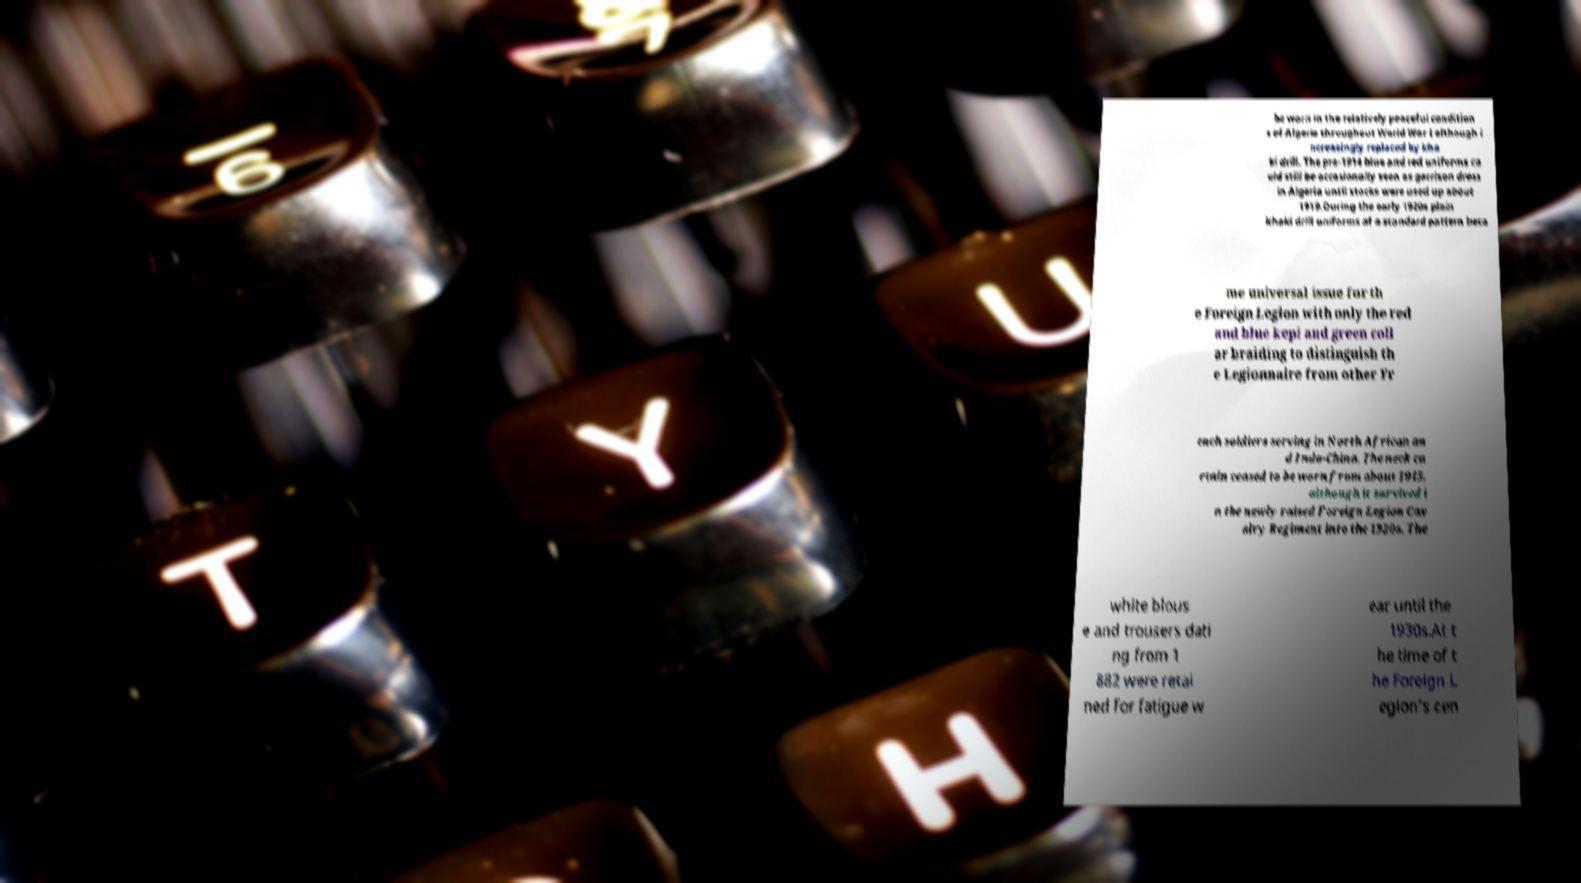Can you read and provide the text displayed in the image?This photo seems to have some interesting text. Can you extract and type it out for me? be worn in the relatively peaceful condition s of Algeria throughout World War I although i ncreasingly replaced by kha ki drill. The pre-1914 blue and red uniforms co uld still be occasionally seen as garrison dress in Algeria until stocks were used up about 1919.During the early 1920s plain khaki drill uniforms of a standard pattern beca me universal issue for th e Foreign Legion with only the red and blue kepi and green coll ar braiding to distinguish th e Legionnaire from other Fr ench soldiers serving in North African an d Indo-China. The neck cu rtain ceased to be worn from about 1915, although it survived i n the newly raised Foreign Legion Cav alry Regiment into the 1920s. The white blous e and trousers dati ng from 1 882 were retai ned for fatigue w ear until the 1930s.At t he time of t he Foreign L egion's cen 